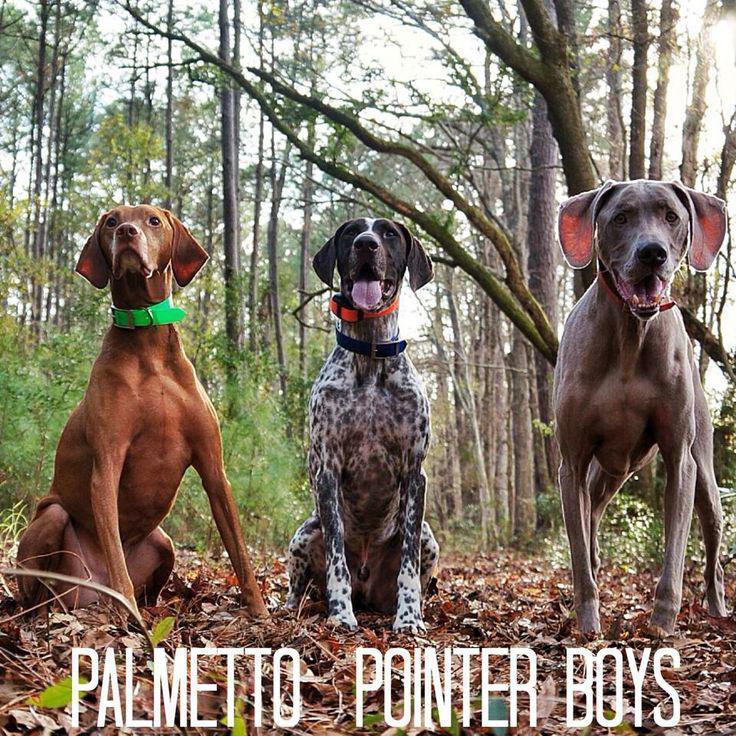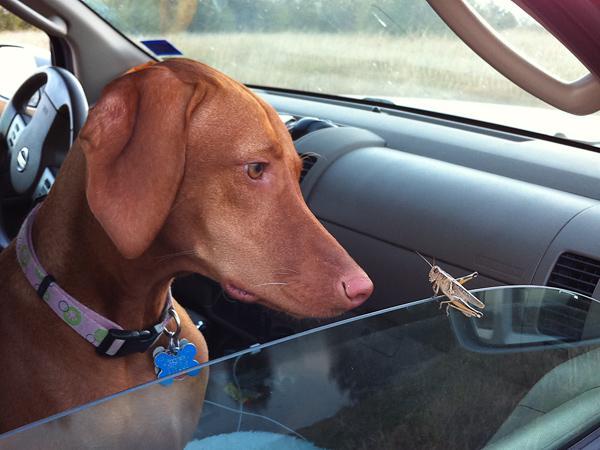The first image is the image on the left, the second image is the image on the right. Evaluate the accuracy of this statement regarding the images: "There are 3 dogs in one of the images and only 1 dog in the other image.". Is it true? Answer yes or no. Yes. The first image is the image on the left, the second image is the image on the right. Analyze the images presented: Is the assertion "The combined images include three dogs posed in a row with their heads close together and at least two the same color, and a metal fence by a red-orange dog." valid? Answer yes or no. No. 